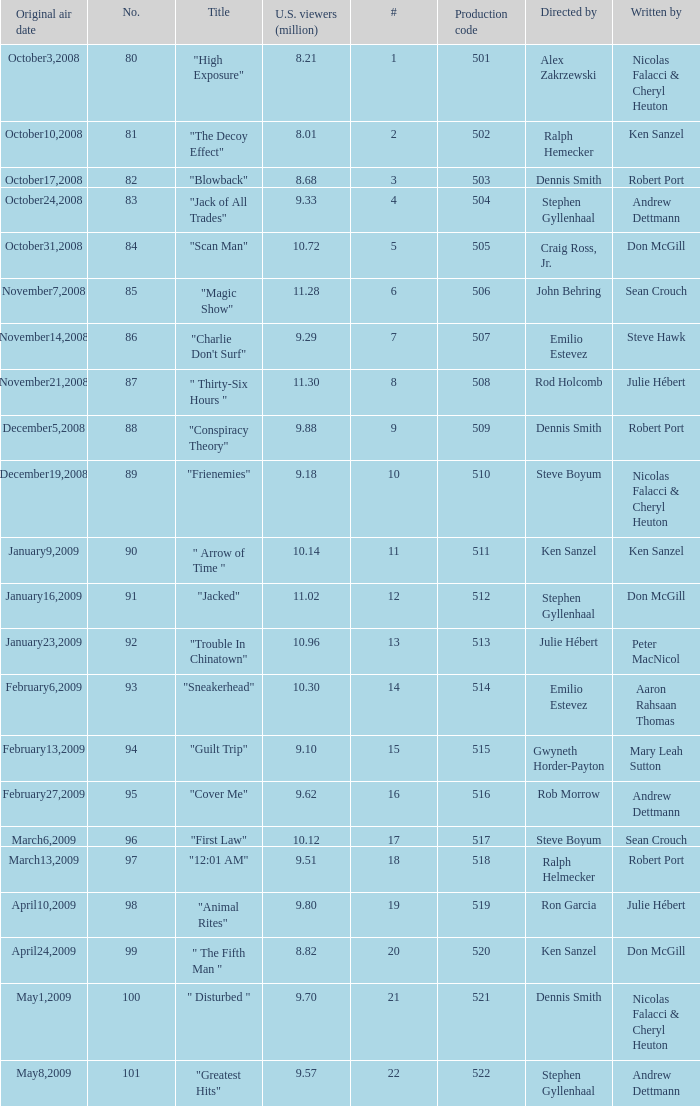What episode had 10.14 million viewers (U.S.)? 11.0. 